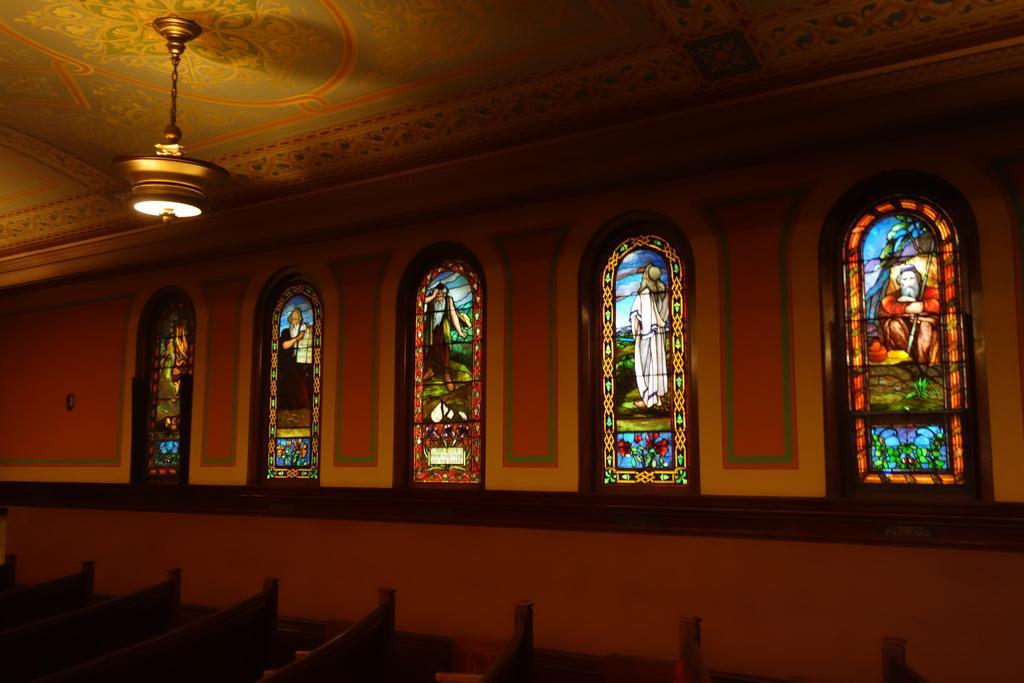Describe this image in one or two sentences. The image is taken in the church. In the center of the image there are glasses designed with pictures. At the bottom there are benches. At the top there is light. 